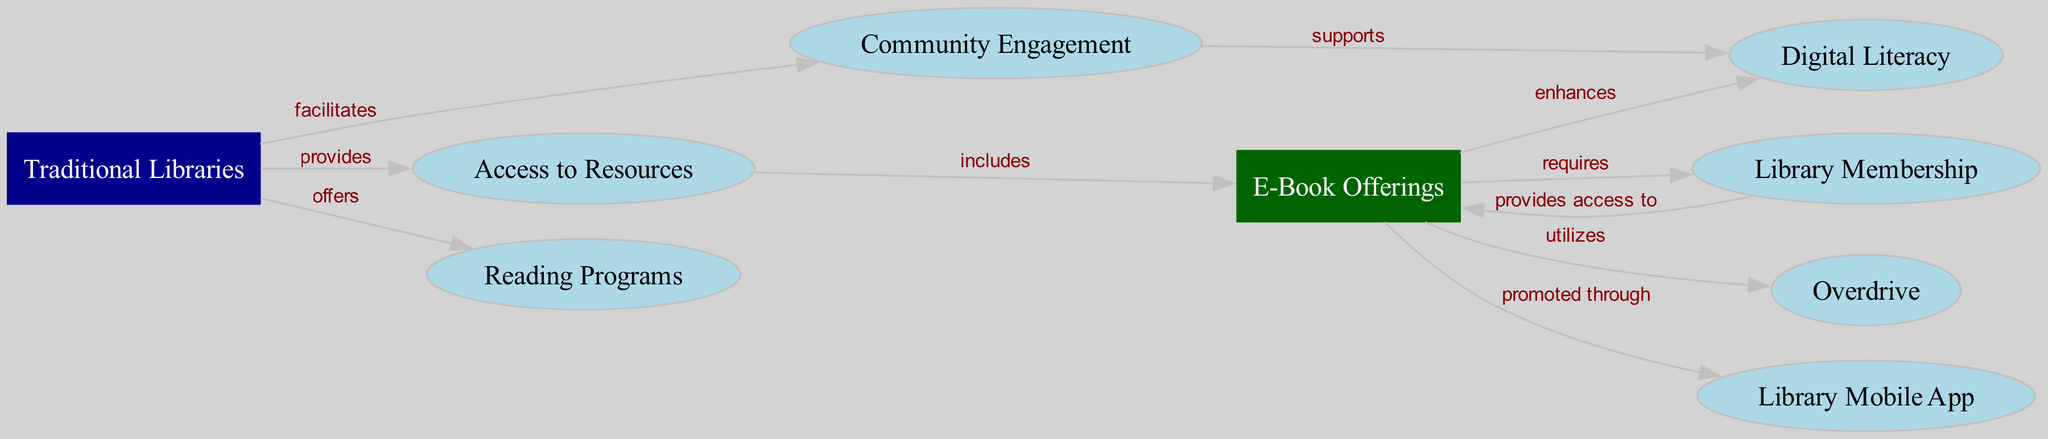What is the total number of nodes in the diagram? To find out the total number of nodes, we can count each unique entity listed in the "nodes" section of the data. There are eight nodes: Traditional Libraries, E-Book Offerings, Community Engagement, Access to Resources, Reading Programs, Digital Literacy, Library Membership, Overdrive, and Library Mobile App.
Answer: 8 What is the relationship between "Traditional Libraries" and "Community Engagement"? The diagram shows a directed edge from "Traditional Libraries" to "Community Engagement" labeled "facilitates", indicating that traditional libraries facilitate community engagement.
Answer: facilitates How many edges are there from "E-Book Offerings"? By examining the "edges" section, we can identify all connections stemming from "E-Book Offerings". There are four edges originating from "E-Book Offerings": to "Digital Literacy", "Library Membership", "Overdrive", and "Library App".
Answer: 4 Which service improves "Digital Literacy"? According to the diagram, "E-Book Offerings" has a direct edge leading to "Digital Literacy", labeled "enhances", which indicates that e-book offerings improve digital literacy.
Answer: E-Book Offerings What service supports "Digital Literacy"? The diagram shows a directed edge from "Community Engagement" to "Digital Literacy" with the label "supports", meaning that community engagement supports digital literacy.
Answer: Community Engagement How does "Access to Resources" relate to "E-Book Offerings"? The relationship can be found in the edge going from "Access to Resources" to "E-Book Offerings" marked "includes", which implies that access to resources includes e-book offerings.
Answer: includes What provides access to "E-Book Offerings"? According to the directed edge from "Library Membership" to "E-Book Offerings", the label "provides access to" indicates that library membership provides access to e-book offerings.
Answer: Library Membership What promotes the use of "Library Mobile App"? The directed edge from "E-Book Offerings" to "Library Mobile App" is labeled "promoted through", indicating that e-book offerings promote the use of the library mobile app.
Answer: E-Book Offerings 